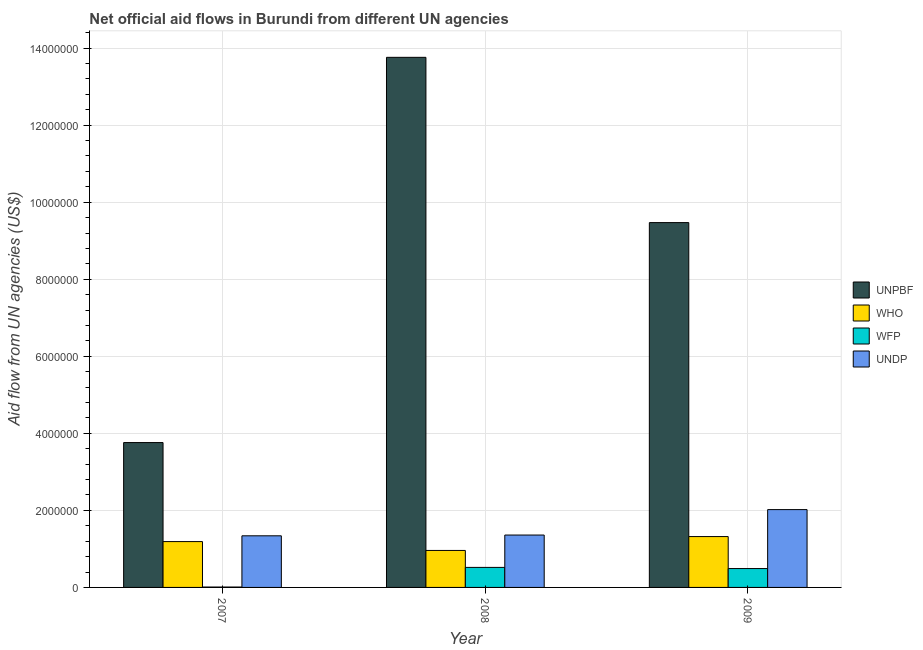How many groups of bars are there?
Provide a succinct answer. 3. Are the number of bars per tick equal to the number of legend labels?
Your answer should be very brief. Yes. Are the number of bars on each tick of the X-axis equal?
Your answer should be very brief. Yes. How many bars are there on the 1st tick from the left?
Keep it short and to the point. 4. How many bars are there on the 1st tick from the right?
Give a very brief answer. 4. What is the amount of aid given by undp in 2008?
Ensure brevity in your answer.  1.36e+06. Across all years, what is the maximum amount of aid given by unpbf?
Your response must be concise. 1.38e+07. Across all years, what is the minimum amount of aid given by undp?
Offer a terse response. 1.34e+06. In which year was the amount of aid given by wfp maximum?
Keep it short and to the point. 2008. What is the total amount of aid given by who in the graph?
Make the answer very short. 3.47e+06. What is the difference between the amount of aid given by unpbf in 2008 and that in 2009?
Make the answer very short. 4.29e+06. What is the difference between the amount of aid given by wfp in 2008 and the amount of aid given by unpbf in 2007?
Give a very brief answer. 5.10e+05. What is the average amount of aid given by unpbf per year?
Keep it short and to the point. 9.00e+06. In how many years, is the amount of aid given by wfp greater than 10000000 US$?
Make the answer very short. 0. What is the ratio of the amount of aid given by unpbf in 2008 to that in 2009?
Ensure brevity in your answer.  1.45. Is the amount of aid given by unpbf in 2008 less than that in 2009?
Offer a very short reply. No. Is the difference between the amount of aid given by wfp in 2008 and 2009 greater than the difference between the amount of aid given by unpbf in 2008 and 2009?
Keep it short and to the point. No. What is the difference between the highest and the second highest amount of aid given by undp?
Offer a very short reply. 6.60e+05. What is the difference between the highest and the lowest amount of aid given by undp?
Provide a succinct answer. 6.80e+05. Is the sum of the amount of aid given by who in 2007 and 2008 greater than the maximum amount of aid given by wfp across all years?
Your answer should be very brief. Yes. What does the 1st bar from the left in 2009 represents?
Your answer should be very brief. UNPBF. What does the 4th bar from the right in 2008 represents?
Your response must be concise. UNPBF. How many bars are there?
Ensure brevity in your answer.  12. Does the graph contain any zero values?
Your answer should be compact. No. How many legend labels are there?
Keep it short and to the point. 4. How are the legend labels stacked?
Keep it short and to the point. Vertical. What is the title of the graph?
Ensure brevity in your answer.  Net official aid flows in Burundi from different UN agencies. Does "Taxes on goods and services" appear as one of the legend labels in the graph?
Your answer should be very brief. No. What is the label or title of the Y-axis?
Provide a succinct answer. Aid flow from UN agencies (US$). What is the Aid flow from UN agencies (US$) in UNPBF in 2007?
Make the answer very short. 3.76e+06. What is the Aid flow from UN agencies (US$) of WHO in 2007?
Offer a terse response. 1.19e+06. What is the Aid flow from UN agencies (US$) of UNDP in 2007?
Provide a succinct answer. 1.34e+06. What is the Aid flow from UN agencies (US$) of UNPBF in 2008?
Provide a succinct answer. 1.38e+07. What is the Aid flow from UN agencies (US$) of WHO in 2008?
Provide a succinct answer. 9.60e+05. What is the Aid flow from UN agencies (US$) in WFP in 2008?
Offer a terse response. 5.20e+05. What is the Aid flow from UN agencies (US$) in UNDP in 2008?
Your response must be concise. 1.36e+06. What is the Aid flow from UN agencies (US$) in UNPBF in 2009?
Your answer should be very brief. 9.47e+06. What is the Aid flow from UN agencies (US$) of WHO in 2009?
Offer a terse response. 1.32e+06. What is the Aid flow from UN agencies (US$) in UNDP in 2009?
Keep it short and to the point. 2.02e+06. Across all years, what is the maximum Aid flow from UN agencies (US$) in UNPBF?
Offer a very short reply. 1.38e+07. Across all years, what is the maximum Aid flow from UN agencies (US$) in WHO?
Keep it short and to the point. 1.32e+06. Across all years, what is the maximum Aid flow from UN agencies (US$) in WFP?
Your answer should be compact. 5.20e+05. Across all years, what is the maximum Aid flow from UN agencies (US$) of UNDP?
Make the answer very short. 2.02e+06. Across all years, what is the minimum Aid flow from UN agencies (US$) of UNPBF?
Offer a terse response. 3.76e+06. Across all years, what is the minimum Aid flow from UN agencies (US$) in WHO?
Provide a short and direct response. 9.60e+05. Across all years, what is the minimum Aid flow from UN agencies (US$) in WFP?
Provide a short and direct response. 10000. Across all years, what is the minimum Aid flow from UN agencies (US$) of UNDP?
Your answer should be compact. 1.34e+06. What is the total Aid flow from UN agencies (US$) in UNPBF in the graph?
Keep it short and to the point. 2.70e+07. What is the total Aid flow from UN agencies (US$) in WHO in the graph?
Provide a short and direct response. 3.47e+06. What is the total Aid flow from UN agencies (US$) in WFP in the graph?
Your answer should be very brief. 1.02e+06. What is the total Aid flow from UN agencies (US$) of UNDP in the graph?
Offer a terse response. 4.72e+06. What is the difference between the Aid flow from UN agencies (US$) of UNPBF in 2007 and that in 2008?
Ensure brevity in your answer.  -1.00e+07. What is the difference between the Aid flow from UN agencies (US$) of WHO in 2007 and that in 2008?
Make the answer very short. 2.30e+05. What is the difference between the Aid flow from UN agencies (US$) of WFP in 2007 and that in 2008?
Ensure brevity in your answer.  -5.10e+05. What is the difference between the Aid flow from UN agencies (US$) in UNPBF in 2007 and that in 2009?
Give a very brief answer. -5.71e+06. What is the difference between the Aid flow from UN agencies (US$) of WFP in 2007 and that in 2009?
Offer a very short reply. -4.80e+05. What is the difference between the Aid flow from UN agencies (US$) in UNDP in 2007 and that in 2009?
Give a very brief answer. -6.80e+05. What is the difference between the Aid flow from UN agencies (US$) of UNPBF in 2008 and that in 2009?
Ensure brevity in your answer.  4.29e+06. What is the difference between the Aid flow from UN agencies (US$) in WHO in 2008 and that in 2009?
Your answer should be very brief. -3.60e+05. What is the difference between the Aid flow from UN agencies (US$) of WFP in 2008 and that in 2009?
Your answer should be very brief. 3.00e+04. What is the difference between the Aid flow from UN agencies (US$) in UNDP in 2008 and that in 2009?
Give a very brief answer. -6.60e+05. What is the difference between the Aid flow from UN agencies (US$) in UNPBF in 2007 and the Aid flow from UN agencies (US$) in WHO in 2008?
Your answer should be very brief. 2.80e+06. What is the difference between the Aid flow from UN agencies (US$) of UNPBF in 2007 and the Aid flow from UN agencies (US$) of WFP in 2008?
Provide a short and direct response. 3.24e+06. What is the difference between the Aid flow from UN agencies (US$) in UNPBF in 2007 and the Aid flow from UN agencies (US$) in UNDP in 2008?
Your response must be concise. 2.40e+06. What is the difference between the Aid flow from UN agencies (US$) in WHO in 2007 and the Aid flow from UN agencies (US$) in WFP in 2008?
Provide a short and direct response. 6.70e+05. What is the difference between the Aid flow from UN agencies (US$) in WFP in 2007 and the Aid flow from UN agencies (US$) in UNDP in 2008?
Ensure brevity in your answer.  -1.35e+06. What is the difference between the Aid flow from UN agencies (US$) in UNPBF in 2007 and the Aid flow from UN agencies (US$) in WHO in 2009?
Ensure brevity in your answer.  2.44e+06. What is the difference between the Aid flow from UN agencies (US$) of UNPBF in 2007 and the Aid flow from UN agencies (US$) of WFP in 2009?
Keep it short and to the point. 3.27e+06. What is the difference between the Aid flow from UN agencies (US$) of UNPBF in 2007 and the Aid flow from UN agencies (US$) of UNDP in 2009?
Your answer should be very brief. 1.74e+06. What is the difference between the Aid flow from UN agencies (US$) of WHO in 2007 and the Aid flow from UN agencies (US$) of WFP in 2009?
Make the answer very short. 7.00e+05. What is the difference between the Aid flow from UN agencies (US$) of WHO in 2007 and the Aid flow from UN agencies (US$) of UNDP in 2009?
Your response must be concise. -8.30e+05. What is the difference between the Aid flow from UN agencies (US$) of WFP in 2007 and the Aid flow from UN agencies (US$) of UNDP in 2009?
Provide a succinct answer. -2.01e+06. What is the difference between the Aid flow from UN agencies (US$) of UNPBF in 2008 and the Aid flow from UN agencies (US$) of WHO in 2009?
Your answer should be very brief. 1.24e+07. What is the difference between the Aid flow from UN agencies (US$) in UNPBF in 2008 and the Aid flow from UN agencies (US$) in WFP in 2009?
Provide a succinct answer. 1.33e+07. What is the difference between the Aid flow from UN agencies (US$) of UNPBF in 2008 and the Aid flow from UN agencies (US$) of UNDP in 2009?
Your answer should be very brief. 1.17e+07. What is the difference between the Aid flow from UN agencies (US$) in WHO in 2008 and the Aid flow from UN agencies (US$) in WFP in 2009?
Ensure brevity in your answer.  4.70e+05. What is the difference between the Aid flow from UN agencies (US$) of WHO in 2008 and the Aid flow from UN agencies (US$) of UNDP in 2009?
Make the answer very short. -1.06e+06. What is the difference between the Aid flow from UN agencies (US$) in WFP in 2008 and the Aid flow from UN agencies (US$) in UNDP in 2009?
Offer a terse response. -1.50e+06. What is the average Aid flow from UN agencies (US$) in UNPBF per year?
Your answer should be compact. 9.00e+06. What is the average Aid flow from UN agencies (US$) of WHO per year?
Make the answer very short. 1.16e+06. What is the average Aid flow from UN agencies (US$) in WFP per year?
Your answer should be compact. 3.40e+05. What is the average Aid flow from UN agencies (US$) in UNDP per year?
Your response must be concise. 1.57e+06. In the year 2007, what is the difference between the Aid flow from UN agencies (US$) of UNPBF and Aid flow from UN agencies (US$) of WHO?
Provide a short and direct response. 2.57e+06. In the year 2007, what is the difference between the Aid flow from UN agencies (US$) of UNPBF and Aid flow from UN agencies (US$) of WFP?
Make the answer very short. 3.75e+06. In the year 2007, what is the difference between the Aid flow from UN agencies (US$) of UNPBF and Aid flow from UN agencies (US$) of UNDP?
Your answer should be compact. 2.42e+06. In the year 2007, what is the difference between the Aid flow from UN agencies (US$) of WHO and Aid flow from UN agencies (US$) of WFP?
Give a very brief answer. 1.18e+06. In the year 2007, what is the difference between the Aid flow from UN agencies (US$) of WHO and Aid flow from UN agencies (US$) of UNDP?
Ensure brevity in your answer.  -1.50e+05. In the year 2007, what is the difference between the Aid flow from UN agencies (US$) of WFP and Aid flow from UN agencies (US$) of UNDP?
Your response must be concise. -1.33e+06. In the year 2008, what is the difference between the Aid flow from UN agencies (US$) in UNPBF and Aid flow from UN agencies (US$) in WHO?
Give a very brief answer. 1.28e+07. In the year 2008, what is the difference between the Aid flow from UN agencies (US$) in UNPBF and Aid flow from UN agencies (US$) in WFP?
Make the answer very short. 1.32e+07. In the year 2008, what is the difference between the Aid flow from UN agencies (US$) of UNPBF and Aid flow from UN agencies (US$) of UNDP?
Provide a short and direct response. 1.24e+07. In the year 2008, what is the difference between the Aid flow from UN agencies (US$) of WHO and Aid flow from UN agencies (US$) of UNDP?
Ensure brevity in your answer.  -4.00e+05. In the year 2008, what is the difference between the Aid flow from UN agencies (US$) in WFP and Aid flow from UN agencies (US$) in UNDP?
Offer a terse response. -8.40e+05. In the year 2009, what is the difference between the Aid flow from UN agencies (US$) of UNPBF and Aid flow from UN agencies (US$) of WHO?
Provide a succinct answer. 8.15e+06. In the year 2009, what is the difference between the Aid flow from UN agencies (US$) in UNPBF and Aid flow from UN agencies (US$) in WFP?
Make the answer very short. 8.98e+06. In the year 2009, what is the difference between the Aid flow from UN agencies (US$) in UNPBF and Aid flow from UN agencies (US$) in UNDP?
Give a very brief answer. 7.45e+06. In the year 2009, what is the difference between the Aid flow from UN agencies (US$) in WHO and Aid flow from UN agencies (US$) in WFP?
Make the answer very short. 8.30e+05. In the year 2009, what is the difference between the Aid flow from UN agencies (US$) of WHO and Aid flow from UN agencies (US$) of UNDP?
Offer a very short reply. -7.00e+05. In the year 2009, what is the difference between the Aid flow from UN agencies (US$) of WFP and Aid flow from UN agencies (US$) of UNDP?
Your response must be concise. -1.53e+06. What is the ratio of the Aid flow from UN agencies (US$) of UNPBF in 2007 to that in 2008?
Provide a short and direct response. 0.27. What is the ratio of the Aid flow from UN agencies (US$) of WHO in 2007 to that in 2008?
Provide a succinct answer. 1.24. What is the ratio of the Aid flow from UN agencies (US$) of WFP in 2007 to that in 2008?
Keep it short and to the point. 0.02. What is the ratio of the Aid flow from UN agencies (US$) of UNPBF in 2007 to that in 2009?
Keep it short and to the point. 0.4. What is the ratio of the Aid flow from UN agencies (US$) of WHO in 2007 to that in 2009?
Keep it short and to the point. 0.9. What is the ratio of the Aid flow from UN agencies (US$) in WFP in 2007 to that in 2009?
Give a very brief answer. 0.02. What is the ratio of the Aid flow from UN agencies (US$) of UNDP in 2007 to that in 2009?
Give a very brief answer. 0.66. What is the ratio of the Aid flow from UN agencies (US$) of UNPBF in 2008 to that in 2009?
Offer a very short reply. 1.45. What is the ratio of the Aid flow from UN agencies (US$) in WHO in 2008 to that in 2009?
Offer a terse response. 0.73. What is the ratio of the Aid flow from UN agencies (US$) of WFP in 2008 to that in 2009?
Offer a very short reply. 1.06. What is the ratio of the Aid flow from UN agencies (US$) of UNDP in 2008 to that in 2009?
Ensure brevity in your answer.  0.67. What is the difference between the highest and the second highest Aid flow from UN agencies (US$) of UNPBF?
Provide a short and direct response. 4.29e+06. What is the difference between the highest and the second highest Aid flow from UN agencies (US$) of UNDP?
Keep it short and to the point. 6.60e+05. What is the difference between the highest and the lowest Aid flow from UN agencies (US$) in WHO?
Give a very brief answer. 3.60e+05. What is the difference between the highest and the lowest Aid flow from UN agencies (US$) of WFP?
Make the answer very short. 5.10e+05. What is the difference between the highest and the lowest Aid flow from UN agencies (US$) of UNDP?
Your answer should be very brief. 6.80e+05. 